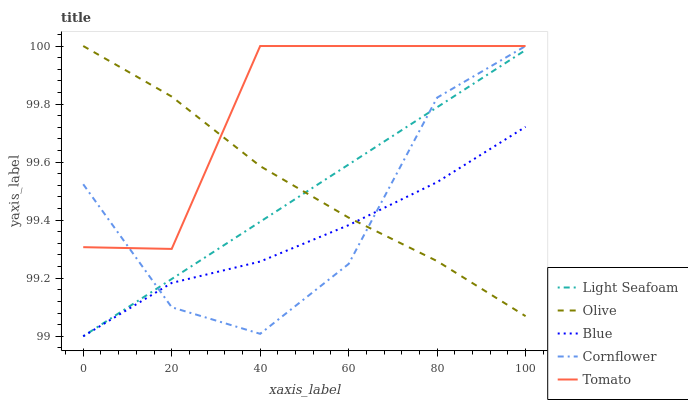Does Blue have the minimum area under the curve?
Answer yes or no. Yes. Does Tomato have the maximum area under the curve?
Answer yes or no. Yes. Does Tomato have the minimum area under the curve?
Answer yes or no. No. Does Blue have the maximum area under the curve?
Answer yes or no. No. Is Light Seafoam the smoothest?
Answer yes or no. Yes. Is Tomato the roughest?
Answer yes or no. Yes. Is Blue the smoothest?
Answer yes or no. No. Is Blue the roughest?
Answer yes or no. No. Does Blue have the lowest value?
Answer yes or no. Yes. Does Tomato have the lowest value?
Answer yes or no. No. Does Cornflower have the highest value?
Answer yes or no. Yes. Does Blue have the highest value?
Answer yes or no. No. Is Blue less than Tomato?
Answer yes or no. Yes. Is Tomato greater than Light Seafoam?
Answer yes or no. Yes. Does Cornflower intersect Blue?
Answer yes or no. Yes. Is Cornflower less than Blue?
Answer yes or no. No. Is Cornflower greater than Blue?
Answer yes or no. No. Does Blue intersect Tomato?
Answer yes or no. No. 